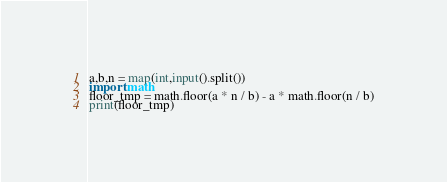<code> <loc_0><loc_0><loc_500><loc_500><_Python_>a,b,n = map(int,input().split())
import math
floor_tmp = math.floor(a * n / b) - a * math.floor(n / b)
print(floor_tmp)</code> 